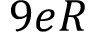Convert formula to latex. <formula><loc_0><loc_0><loc_500><loc_500>9 e R</formula> 